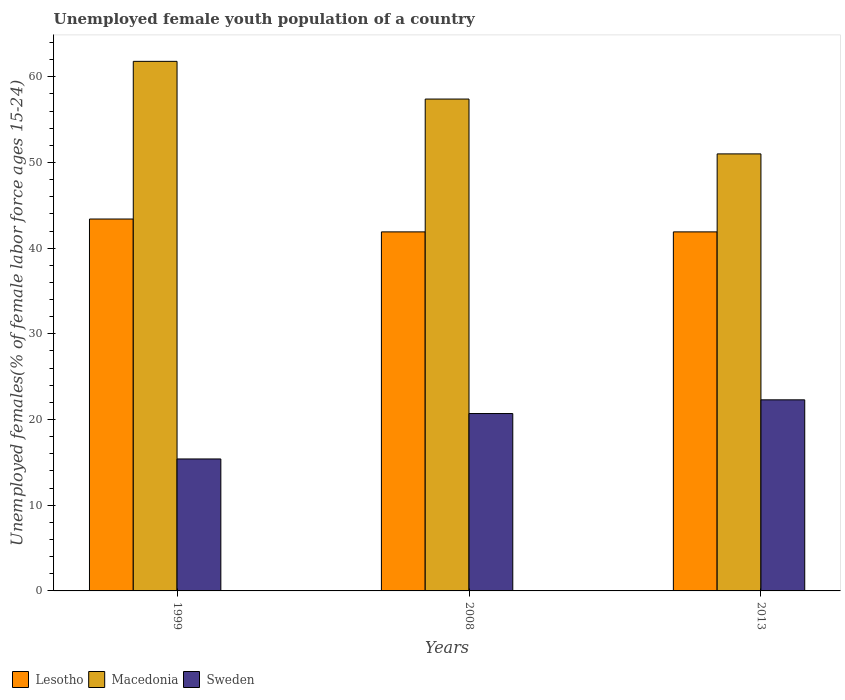What is the percentage of unemployed female youth population in Sweden in 1999?
Your answer should be compact. 15.4. Across all years, what is the maximum percentage of unemployed female youth population in Macedonia?
Make the answer very short. 61.8. Across all years, what is the minimum percentage of unemployed female youth population in Sweden?
Your answer should be compact. 15.4. In which year was the percentage of unemployed female youth population in Macedonia maximum?
Offer a terse response. 1999. In which year was the percentage of unemployed female youth population in Lesotho minimum?
Offer a very short reply. 2008. What is the total percentage of unemployed female youth population in Lesotho in the graph?
Keep it short and to the point. 127.2. What is the difference between the percentage of unemployed female youth population in Macedonia in 1999 and that in 2013?
Your response must be concise. 10.8. What is the difference between the percentage of unemployed female youth population in Sweden in 2008 and the percentage of unemployed female youth population in Macedonia in 2013?
Make the answer very short. -30.3. What is the average percentage of unemployed female youth population in Sweden per year?
Offer a terse response. 19.47. In the year 2008, what is the difference between the percentage of unemployed female youth population in Sweden and percentage of unemployed female youth population in Lesotho?
Your response must be concise. -21.2. In how many years, is the percentage of unemployed female youth population in Sweden greater than 44 %?
Give a very brief answer. 0. What is the difference between the highest and the second highest percentage of unemployed female youth population in Macedonia?
Your response must be concise. 4.4. What is the difference between the highest and the lowest percentage of unemployed female youth population in Lesotho?
Your answer should be compact. 1.5. In how many years, is the percentage of unemployed female youth population in Lesotho greater than the average percentage of unemployed female youth population in Lesotho taken over all years?
Make the answer very short. 1. What does the 3rd bar from the left in 2008 represents?
Offer a very short reply. Sweden. What does the 2nd bar from the right in 2013 represents?
Provide a short and direct response. Macedonia. Is it the case that in every year, the sum of the percentage of unemployed female youth population in Lesotho and percentage of unemployed female youth population in Sweden is greater than the percentage of unemployed female youth population in Macedonia?
Ensure brevity in your answer.  No. How many bars are there?
Give a very brief answer. 9. Are the values on the major ticks of Y-axis written in scientific E-notation?
Ensure brevity in your answer.  No. Does the graph contain grids?
Offer a very short reply. No. How are the legend labels stacked?
Keep it short and to the point. Horizontal. What is the title of the graph?
Your answer should be compact. Unemployed female youth population of a country. What is the label or title of the Y-axis?
Provide a succinct answer. Unemployed females(% of female labor force ages 15-24). What is the Unemployed females(% of female labor force ages 15-24) of Lesotho in 1999?
Offer a very short reply. 43.4. What is the Unemployed females(% of female labor force ages 15-24) in Macedonia in 1999?
Keep it short and to the point. 61.8. What is the Unemployed females(% of female labor force ages 15-24) of Sweden in 1999?
Offer a terse response. 15.4. What is the Unemployed females(% of female labor force ages 15-24) in Lesotho in 2008?
Ensure brevity in your answer.  41.9. What is the Unemployed females(% of female labor force ages 15-24) in Macedonia in 2008?
Your answer should be compact. 57.4. What is the Unemployed females(% of female labor force ages 15-24) in Sweden in 2008?
Offer a terse response. 20.7. What is the Unemployed females(% of female labor force ages 15-24) of Lesotho in 2013?
Provide a short and direct response. 41.9. What is the Unemployed females(% of female labor force ages 15-24) in Sweden in 2013?
Your response must be concise. 22.3. Across all years, what is the maximum Unemployed females(% of female labor force ages 15-24) in Lesotho?
Ensure brevity in your answer.  43.4. Across all years, what is the maximum Unemployed females(% of female labor force ages 15-24) of Macedonia?
Provide a succinct answer. 61.8. Across all years, what is the maximum Unemployed females(% of female labor force ages 15-24) in Sweden?
Provide a succinct answer. 22.3. Across all years, what is the minimum Unemployed females(% of female labor force ages 15-24) of Lesotho?
Make the answer very short. 41.9. Across all years, what is the minimum Unemployed females(% of female labor force ages 15-24) of Macedonia?
Make the answer very short. 51. Across all years, what is the minimum Unemployed females(% of female labor force ages 15-24) in Sweden?
Offer a very short reply. 15.4. What is the total Unemployed females(% of female labor force ages 15-24) in Lesotho in the graph?
Provide a succinct answer. 127.2. What is the total Unemployed females(% of female labor force ages 15-24) of Macedonia in the graph?
Provide a succinct answer. 170.2. What is the total Unemployed females(% of female labor force ages 15-24) of Sweden in the graph?
Provide a short and direct response. 58.4. What is the difference between the Unemployed females(% of female labor force ages 15-24) of Macedonia in 1999 and that in 2013?
Provide a short and direct response. 10.8. What is the difference between the Unemployed females(% of female labor force ages 15-24) of Macedonia in 2008 and that in 2013?
Offer a very short reply. 6.4. What is the difference between the Unemployed females(% of female labor force ages 15-24) of Sweden in 2008 and that in 2013?
Make the answer very short. -1.6. What is the difference between the Unemployed females(% of female labor force ages 15-24) in Lesotho in 1999 and the Unemployed females(% of female labor force ages 15-24) in Macedonia in 2008?
Your answer should be very brief. -14. What is the difference between the Unemployed females(% of female labor force ages 15-24) of Lesotho in 1999 and the Unemployed females(% of female labor force ages 15-24) of Sweden in 2008?
Your response must be concise. 22.7. What is the difference between the Unemployed females(% of female labor force ages 15-24) of Macedonia in 1999 and the Unemployed females(% of female labor force ages 15-24) of Sweden in 2008?
Your answer should be very brief. 41.1. What is the difference between the Unemployed females(% of female labor force ages 15-24) of Lesotho in 1999 and the Unemployed females(% of female labor force ages 15-24) of Sweden in 2013?
Offer a terse response. 21.1. What is the difference between the Unemployed females(% of female labor force ages 15-24) in Macedonia in 1999 and the Unemployed females(% of female labor force ages 15-24) in Sweden in 2013?
Your answer should be compact. 39.5. What is the difference between the Unemployed females(% of female labor force ages 15-24) in Lesotho in 2008 and the Unemployed females(% of female labor force ages 15-24) in Sweden in 2013?
Make the answer very short. 19.6. What is the difference between the Unemployed females(% of female labor force ages 15-24) in Macedonia in 2008 and the Unemployed females(% of female labor force ages 15-24) in Sweden in 2013?
Make the answer very short. 35.1. What is the average Unemployed females(% of female labor force ages 15-24) of Lesotho per year?
Provide a short and direct response. 42.4. What is the average Unemployed females(% of female labor force ages 15-24) of Macedonia per year?
Provide a succinct answer. 56.73. What is the average Unemployed females(% of female labor force ages 15-24) of Sweden per year?
Offer a terse response. 19.47. In the year 1999, what is the difference between the Unemployed females(% of female labor force ages 15-24) in Lesotho and Unemployed females(% of female labor force ages 15-24) in Macedonia?
Provide a succinct answer. -18.4. In the year 1999, what is the difference between the Unemployed females(% of female labor force ages 15-24) in Lesotho and Unemployed females(% of female labor force ages 15-24) in Sweden?
Offer a very short reply. 28. In the year 1999, what is the difference between the Unemployed females(% of female labor force ages 15-24) of Macedonia and Unemployed females(% of female labor force ages 15-24) of Sweden?
Keep it short and to the point. 46.4. In the year 2008, what is the difference between the Unemployed females(% of female labor force ages 15-24) of Lesotho and Unemployed females(% of female labor force ages 15-24) of Macedonia?
Make the answer very short. -15.5. In the year 2008, what is the difference between the Unemployed females(% of female labor force ages 15-24) of Lesotho and Unemployed females(% of female labor force ages 15-24) of Sweden?
Provide a succinct answer. 21.2. In the year 2008, what is the difference between the Unemployed females(% of female labor force ages 15-24) of Macedonia and Unemployed females(% of female labor force ages 15-24) of Sweden?
Offer a terse response. 36.7. In the year 2013, what is the difference between the Unemployed females(% of female labor force ages 15-24) of Lesotho and Unemployed females(% of female labor force ages 15-24) of Sweden?
Ensure brevity in your answer.  19.6. In the year 2013, what is the difference between the Unemployed females(% of female labor force ages 15-24) of Macedonia and Unemployed females(% of female labor force ages 15-24) of Sweden?
Your response must be concise. 28.7. What is the ratio of the Unemployed females(% of female labor force ages 15-24) in Lesotho in 1999 to that in 2008?
Ensure brevity in your answer.  1.04. What is the ratio of the Unemployed females(% of female labor force ages 15-24) in Macedonia in 1999 to that in 2008?
Provide a succinct answer. 1.08. What is the ratio of the Unemployed females(% of female labor force ages 15-24) in Sweden in 1999 to that in 2008?
Your answer should be very brief. 0.74. What is the ratio of the Unemployed females(% of female labor force ages 15-24) in Lesotho in 1999 to that in 2013?
Offer a terse response. 1.04. What is the ratio of the Unemployed females(% of female labor force ages 15-24) of Macedonia in 1999 to that in 2013?
Keep it short and to the point. 1.21. What is the ratio of the Unemployed females(% of female labor force ages 15-24) in Sweden in 1999 to that in 2013?
Make the answer very short. 0.69. What is the ratio of the Unemployed females(% of female labor force ages 15-24) of Macedonia in 2008 to that in 2013?
Keep it short and to the point. 1.13. What is the ratio of the Unemployed females(% of female labor force ages 15-24) of Sweden in 2008 to that in 2013?
Your answer should be very brief. 0.93. What is the difference between the highest and the second highest Unemployed females(% of female labor force ages 15-24) of Lesotho?
Keep it short and to the point. 1.5. What is the difference between the highest and the second highest Unemployed females(% of female labor force ages 15-24) in Macedonia?
Your response must be concise. 4.4. What is the difference between the highest and the lowest Unemployed females(% of female labor force ages 15-24) in Sweden?
Provide a short and direct response. 6.9. 